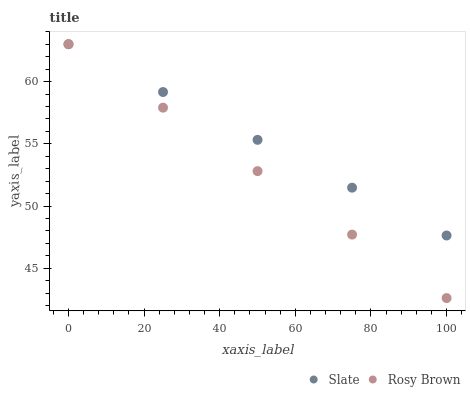Does Rosy Brown have the minimum area under the curve?
Answer yes or no. Yes. Does Slate have the maximum area under the curve?
Answer yes or no. Yes. Does Rosy Brown have the maximum area under the curve?
Answer yes or no. No. Is Slate the smoothest?
Answer yes or no. Yes. Is Rosy Brown the roughest?
Answer yes or no. Yes. Does Rosy Brown have the lowest value?
Answer yes or no. Yes. Does Rosy Brown have the highest value?
Answer yes or no. Yes. Does Slate intersect Rosy Brown?
Answer yes or no. Yes. Is Slate less than Rosy Brown?
Answer yes or no. No. Is Slate greater than Rosy Brown?
Answer yes or no. No. 